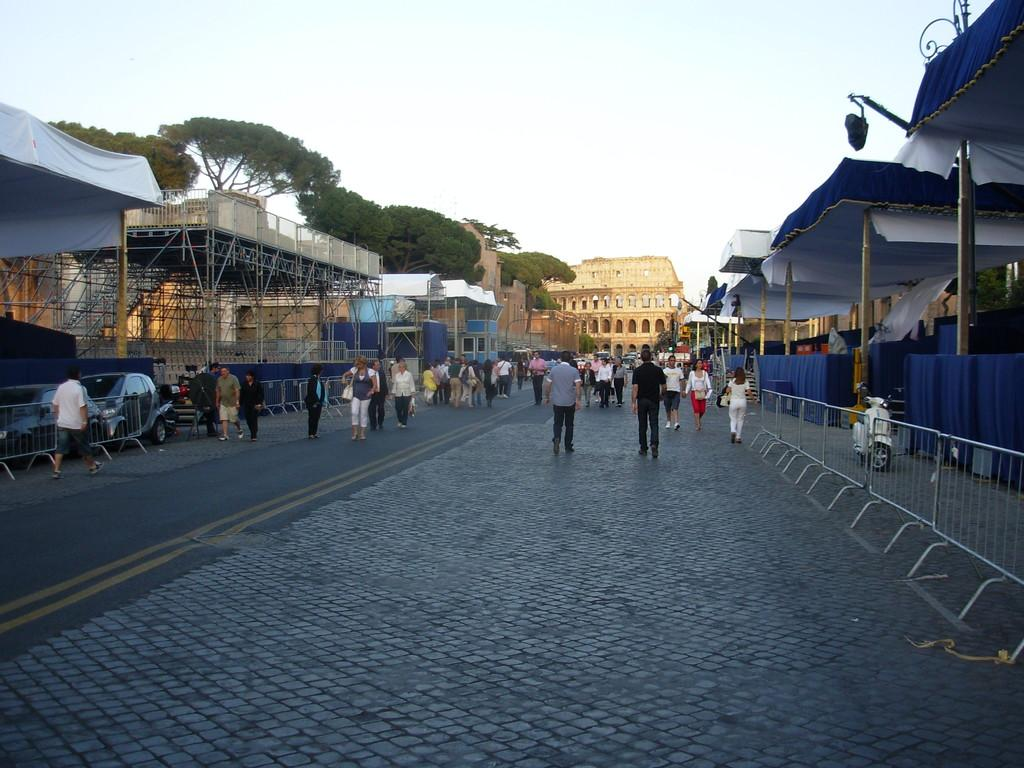What is happening on the road in the image? There are people and vehicles on the road in the image. What can be seen in the image besides the road? There are fences, buildings, tents, trees, and some unspecified objects in the image. What is visible in the background of the image? The sky is visible in the background of the image. What type of wax can be seen melting on the grip of the vehicle in the image? There is no wax or grip visible on any vehicle in the image. Where is the office located in the image? There is no office present in the image. 